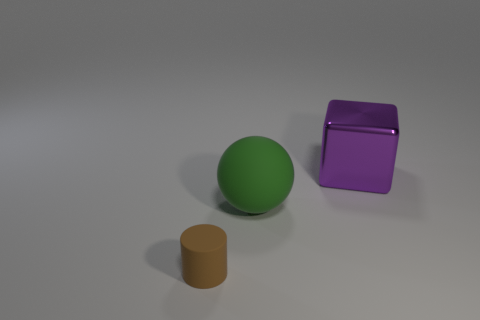Add 1 brown cylinders. How many objects exist? 4 Add 3 shiny cubes. How many shiny cubes exist? 4 Subtract 0 cyan cylinders. How many objects are left? 3 Subtract 1 cylinders. How many cylinders are left? 0 Subtract all yellow cylinders. Subtract all blue blocks. How many cylinders are left? 1 Subtract all green blocks. How many gray cylinders are left? 0 Subtract all big cyan metallic balls. Subtract all large metal blocks. How many objects are left? 2 Add 1 tiny rubber objects. How many tiny rubber objects are left? 2 